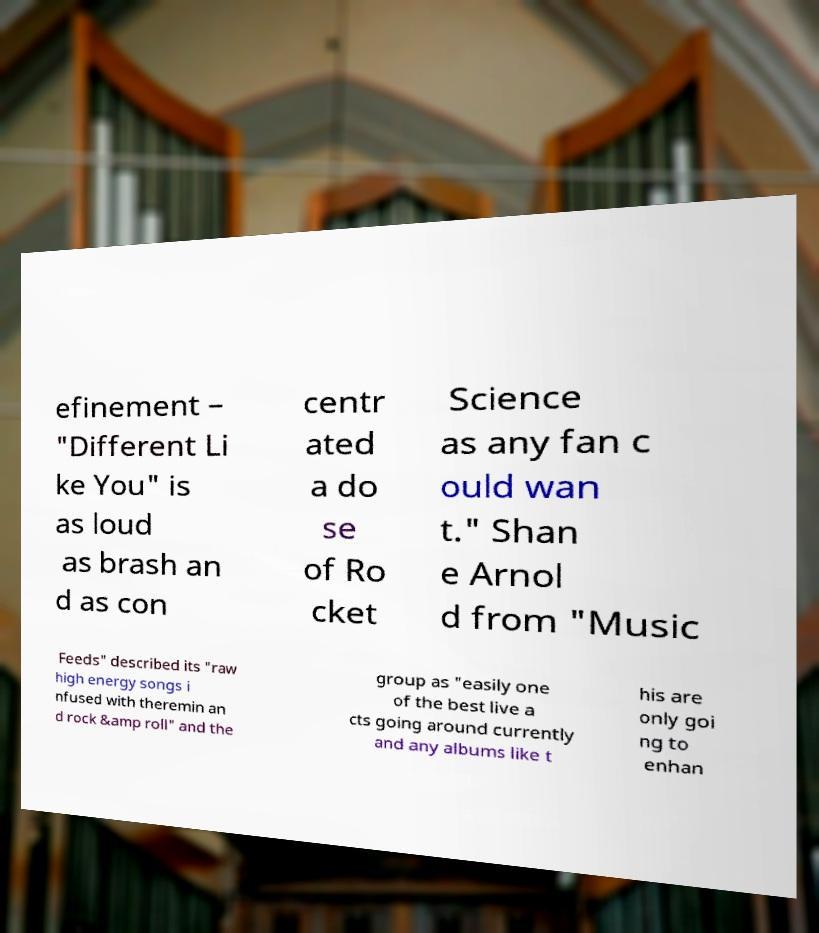Could you assist in decoding the text presented in this image and type it out clearly? efinement – "Different Li ke You" is as loud as brash an d as con centr ated a do se of Ro cket Science as any fan c ould wan t." Shan e Arnol d from "Music Feeds" described its "raw high energy songs i nfused with theremin an d rock &amp roll" and the group as "easily one of the best live a cts going around currently and any albums like t his are only goi ng to enhan 